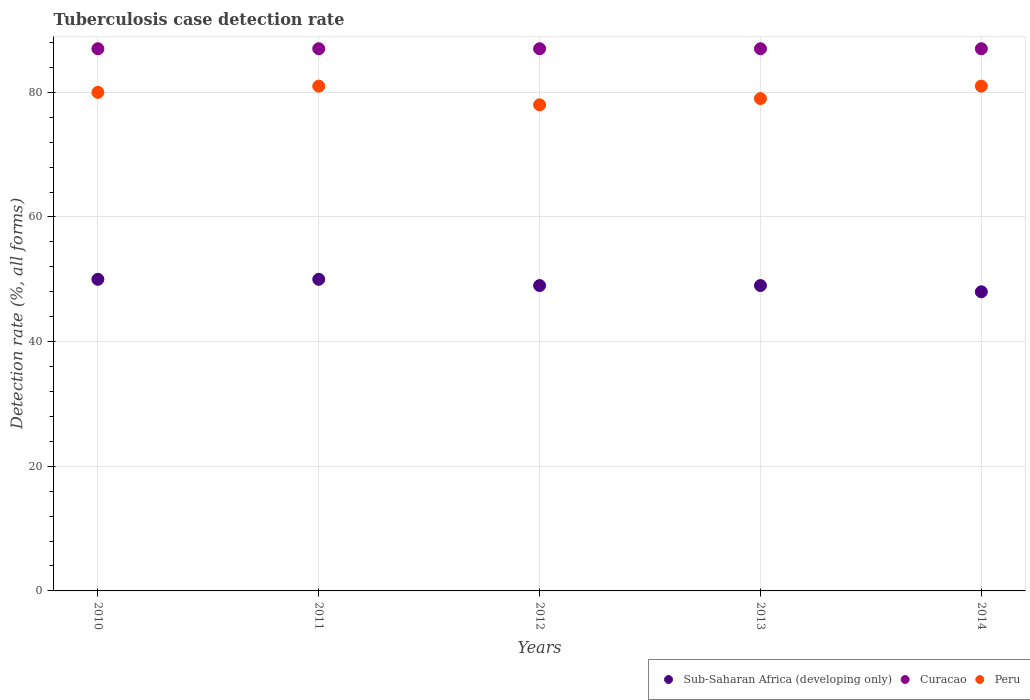How many different coloured dotlines are there?
Your answer should be very brief. 3. What is the tuberculosis case detection rate in in Sub-Saharan Africa (developing only) in 2011?
Provide a short and direct response. 50. Across all years, what is the maximum tuberculosis case detection rate in in Sub-Saharan Africa (developing only)?
Provide a succinct answer. 50. Across all years, what is the minimum tuberculosis case detection rate in in Curacao?
Keep it short and to the point. 87. In which year was the tuberculosis case detection rate in in Peru maximum?
Offer a terse response. 2011. In which year was the tuberculosis case detection rate in in Curacao minimum?
Ensure brevity in your answer.  2010. What is the total tuberculosis case detection rate in in Sub-Saharan Africa (developing only) in the graph?
Give a very brief answer. 246. What is the difference between the tuberculosis case detection rate in in Peru in 2011 and that in 2012?
Your answer should be very brief. 3. What is the difference between the tuberculosis case detection rate in in Peru in 2010 and the tuberculosis case detection rate in in Sub-Saharan Africa (developing only) in 2012?
Keep it short and to the point. 31. What is the average tuberculosis case detection rate in in Sub-Saharan Africa (developing only) per year?
Ensure brevity in your answer.  49.2. In the year 2013, what is the difference between the tuberculosis case detection rate in in Sub-Saharan Africa (developing only) and tuberculosis case detection rate in in Peru?
Give a very brief answer. -30. In how many years, is the tuberculosis case detection rate in in Sub-Saharan Africa (developing only) greater than 52 %?
Provide a succinct answer. 0. What is the ratio of the tuberculosis case detection rate in in Sub-Saharan Africa (developing only) in 2010 to that in 2012?
Provide a short and direct response. 1.02. What is the difference between the highest and the second highest tuberculosis case detection rate in in Sub-Saharan Africa (developing only)?
Offer a very short reply. 0. What is the difference between the highest and the lowest tuberculosis case detection rate in in Curacao?
Make the answer very short. 0. Is it the case that in every year, the sum of the tuberculosis case detection rate in in Sub-Saharan Africa (developing only) and tuberculosis case detection rate in in Curacao  is greater than the tuberculosis case detection rate in in Peru?
Offer a terse response. Yes. Is the tuberculosis case detection rate in in Peru strictly greater than the tuberculosis case detection rate in in Sub-Saharan Africa (developing only) over the years?
Make the answer very short. Yes. How many years are there in the graph?
Your answer should be very brief. 5. Are the values on the major ticks of Y-axis written in scientific E-notation?
Your answer should be compact. No. Does the graph contain any zero values?
Provide a succinct answer. No. Does the graph contain grids?
Your response must be concise. Yes. How are the legend labels stacked?
Keep it short and to the point. Horizontal. What is the title of the graph?
Give a very brief answer. Tuberculosis case detection rate. What is the label or title of the Y-axis?
Provide a short and direct response. Detection rate (%, all forms). What is the Detection rate (%, all forms) of Peru in 2010?
Provide a succinct answer. 80. What is the Detection rate (%, all forms) in Sub-Saharan Africa (developing only) in 2011?
Provide a succinct answer. 50. What is the Detection rate (%, all forms) in Curacao in 2011?
Keep it short and to the point. 87. What is the Detection rate (%, all forms) in Peru in 2012?
Make the answer very short. 78. What is the Detection rate (%, all forms) in Peru in 2013?
Ensure brevity in your answer.  79. What is the Detection rate (%, all forms) in Sub-Saharan Africa (developing only) in 2014?
Provide a short and direct response. 48. Across all years, what is the minimum Detection rate (%, all forms) in Curacao?
Your answer should be very brief. 87. What is the total Detection rate (%, all forms) of Sub-Saharan Africa (developing only) in the graph?
Your answer should be very brief. 246. What is the total Detection rate (%, all forms) of Curacao in the graph?
Offer a terse response. 435. What is the total Detection rate (%, all forms) in Peru in the graph?
Provide a short and direct response. 399. What is the difference between the Detection rate (%, all forms) in Sub-Saharan Africa (developing only) in 2010 and that in 2011?
Your answer should be very brief. 0. What is the difference between the Detection rate (%, all forms) in Peru in 2010 and that in 2011?
Give a very brief answer. -1. What is the difference between the Detection rate (%, all forms) in Peru in 2010 and that in 2014?
Provide a short and direct response. -1. What is the difference between the Detection rate (%, all forms) of Curacao in 2011 and that in 2012?
Keep it short and to the point. 0. What is the difference between the Detection rate (%, all forms) of Peru in 2011 and that in 2012?
Make the answer very short. 3. What is the difference between the Detection rate (%, all forms) in Sub-Saharan Africa (developing only) in 2011 and that in 2014?
Ensure brevity in your answer.  2. What is the difference between the Detection rate (%, all forms) in Peru in 2011 and that in 2014?
Provide a short and direct response. 0. What is the difference between the Detection rate (%, all forms) in Curacao in 2012 and that in 2013?
Offer a terse response. 0. What is the difference between the Detection rate (%, all forms) of Peru in 2012 and that in 2014?
Provide a short and direct response. -3. What is the difference between the Detection rate (%, all forms) of Curacao in 2013 and that in 2014?
Provide a short and direct response. 0. What is the difference between the Detection rate (%, all forms) of Sub-Saharan Africa (developing only) in 2010 and the Detection rate (%, all forms) of Curacao in 2011?
Offer a very short reply. -37. What is the difference between the Detection rate (%, all forms) in Sub-Saharan Africa (developing only) in 2010 and the Detection rate (%, all forms) in Peru in 2011?
Keep it short and to the point. -31. What is the difference between the Detection rate (%, all forms) of Curacao in 2010 and the Detection rate (%, all forms) of Peru in 2011?
Offer a terse response. 6. What is the difference between the Detection rate (%, all forms) of Sub-Saharan Africa (developing only) in 2010 and the Detection rate (%, all forms) of Curacao in 2012?
Keep it short and to the point. -37. What is the difference between the Detection rate (%, all forms) in Sub-Saharan Africa (developing only) in 2010 and the Detection rate (%, all forms) in Curacao in 2013?
Your answer should be very brief. -37. What is the difference between the Detection rate (%, all forms) in Sub-Saharan Africa (developing only) in 2010 and the Detection rate (%, all forms) in Peru in 2013?
Make the answer very short. -29. What is the difference between the Detection rate (%, all forms) of Curacao in 2010 and the Detection rate (%, all forms) of Peru in 2013?
Your answer should be very brief. 8. What is the difference between the Detection rate (%, all forms) of Sub-Saharan Africa (developing only) in 2010 and the Detection rate (%, all forms) of Curacao in 2014?
Your response must be concise. -37. What is the difference between the Detection rate (%, all forms) in Sub-Saharan Africa (developing only) in 2010 and the Detection rate (%, all forms) in Peru in 2014?
Offer a terse response. -31. What is the difference between the Detection rate (%, all forms) of Sub-Saharan Africa (developing only) in 2011 and the Detection rate (%, all forms) of Curacao in 2012?
Your response must be concise. -37. What is the difference between the Detection rate (%, all forms) of Sub-Saharan Africa (developing only) in 2011 and the Detection rate (%, all forms) of Peru in 2012?
Provide a succinct answer. -28. What is the difference between the Detection rate (%, all forms) in Sub-Saharan Africa (developing only) in 2011 and the Detection rate (%, all forms) in Curacao in 2013?
Ensure brevity in your answer.  -37. What is the difference between the Detection rate (%, all forms) of Sub-Saharan Africa (developing only) in 2011 and the Detection rate (%, all forms) of Peru in 2013?
Provide a short and direct response. -29. What is the difference between the Detection rate (%, all forms) in Sub-Saharan Africa (developing only) in 2011 and the Detection rate (%, all forms) in Curacao in 2014?
Give a very brief answer. -37. What is the difference between the Detection rate (%, all forms) in Sub-Saharan Africa (developing only) in 2011 and the Detection rate (%, all forms) in Peru in 2014?
Provide a succinct answer. -31. What is the difference between the Detection rate (%, all forms) of Sub-Saharan Africa (developing only) in 2012 and the Detection rate (%, all forms) of Curacao in 2013?
Make the answer very short. -38. What is the difference between the Detection rate (%, all forms) in Curacao in 2012 and the Detection rate (%, all forms) in Peru in 2013?
Keep it short and to the point. 8. What is the difference between the Detection rate (%, all forms) in Sub-Saharan Africa (developing only) in 2012 and the Detection rate (%, all forms) in Curacao in 2014?
Offer a terse response. -38. What is the difference between the Detection rate (%, all forms) in Sub-Saharan Africa (developing only) in 2012 and the Detection rate (%, all forms) in Peru in 2014?
Make the answer very short. -32. What is the difference between the Detection rate (%, all forms) in Curacao in 2012 and the Detection rate (%, all forms) in Peru in 2014?
Your response must be concise. 6. What is the difference between the Detection rate (%, all forms) in Sub-Saharan Africa (developing only) in 2013 and the Detection rate (%, all forms) in Curacao in 2014?
Your answer should be compact. -38. What is the difference between the Detection rate (%, all forms) in Sub-Saharan Africa (developing only) in 2013 and the Detection rate (%, all forms) in Peru in 2014?
Ensure brevity in your answer.  -32. What is the average Detection rate (%, all forms) of Sub-Saharan Africa (developing only) per year?
Give a very brief answer. 49.2. What is the average Detection rate (%, all forms) in Peru per year?
Give a very brief answer. 79.8. In the year 2010, what is the difference between the Detection rate (%, all forms) in Sub-Saharan Africa (developing only) and Detection rate (%, all forms) in Curacao?
Ensure brevity in your answer.  -37. In the year 2010, what is the difference between the Detection rate (%, all forms) in Sub-Saharan Africa (developing only) and Detection rate (%, all forms) in Peru?
Your answer should be very brief. -30. In the year 2010, what is the difference between the Detection rate (%, all forms) of Curacao and Detection rate (%, all forms) of Peru?
Make the answer very short. 7. In the year 2011, what is the difference between the Detection rate (%, all forms) of Sub-Saharan Africa (developing only) and Detection rate (%, all forms) of Curacao?
Offer a very short reply. -37. In the year 2011, what is the difference between the Detection rate (%, all forms) in Sub-Saharan Africa (developing only) and Detection rate (%, all forms) in Peru?
Your answer should be very brief. -31. In the year 2011, what is the difference between the Detection rate (%, all forms) of Curacao and Detection rate (%, all forms) of Peru?
Your answer should be compact. 6. In the year 2012, what is the difference between the Detection rate (%, all forms) of Sub-Saharan Africa (developing only) and Detection rate (%, all forms) of Curacao?
Keep it short and to the point. -38. In the year 2012, what is the difference between the Detection rate (%, all forms) of Sub-Saharan Africa (developing only) and Detection rate (%, all forms) of Peru?
Your response must be concise. -29. In the year 2012, what is the difference between the Detection rate (%, all forms) in Curacao and Detection rate (%, all forms) in Peru?
Your response must be concise. 9. In the year 2013, what is the difference between the Detection rate (%, all forms) of Sub-Saharan Africa (developing only) and Detection rate (%, all forms) of Curacao?
Your response must be concise. -38. In the year 2013, what is the difference between the Detection rate (%, all forms) in Sub-Saharan Africa (developing only) and Detection rate (%, all forms) in Peru?
Your response must be concise. -30. In the year 2013, what is the difference between the Detection rate (%, all forms) in Curacao and Detection rate (%, all forms) in Peru?
Offer a terse response. 8. In the year 2014, what is the difference between the Detection rate (%, all forms) of Sub-Saharan Africa (developing only) and Detection rate (%, all forms) of Curacao?
Your answer should be compact. -39. In the year 2014, what is the difference between the Detection rate (%, all forms) in Sub-Saharan Africa (developing only) and Detection rate (%, all forms) in Peru?
Provide a short and direct response. -33. What is the ratio of the Detection rate (%, all forms) of Sub-Saharan Africa (developing only) in 2010 to that in 2012?
Offer a terse response. 1.02. What is the ratio of the Detection rate (%, all forms) in Curacao in 2010 to that in 2012?
Give a very brief answer. 1. What is the ratio of the Detection rate (%, all forms) of Peru in 2010 to that in 2012?
Give a very brief answer. 1.03. What is the ratio of the Detection rate (%, all forms) of Sub-Saharan Africa (developing only) in 2010 to that in 2013?
Offer a very short reply. 1.02. What is the ratio of the Detection rate (%, all forms) in Curacao in 2010 to that in 2013?
Ensure brevity in your answer.  1. What is the ratio of the Detection rate (%, all forms) in Peru in 2010 to that in 2013?
Your response must be concise. 1.01. What is the ratio of the Detection rate (%, all forms) in Sub-Saharan Africa (developing only) in 2010 to that in 2014?
Your answer should be compact. 1.04. What is the ratio of the Detection rate (%, all forms) in Peru in 2010 to that in 2014?
Give a very brief answer. 0.99. What is the ratio of the Detection rate (%, all forms) in Sub-Saharan Africa (developing only) in 2011 to that in 2012?
Offer a very short reply. 1.02. What is the ratio of the Detection rate (%, all forms) in Curacao in 2011 to that in 2012?
Your answer should be compact. 1. What is the ratio of the Detection rate (%, all forms) of Peru in 2011 to that in 2012?
Keep it short and to the point. 1.04. What is the ratio of the Detection rate (%, all forms) in Sub-Saharan Africa (developing only) in 2011 to that in 2013?
Offer a terse response. 1.02. What is the ratio of the Detection rate (%, all forms) in Peru in 2011 to that in 2013?
Provide a succinct answer. 1.03. What is the ratio of the Detection rate (%, all forms) in Sub-Saharan Africa (developing only) in 2011 to that in 2014?
Ensure brevity in your answer.  1.04. What is the ratio of the Detection rate (%, all forms) in Peru in 2011 to that in 2014?
Offer a very short reply. 1. What is the ratio of the Detection rate (%, all forms) of Curacao in 2012 to that in 2013?
Your answer should be compact. 1. What is the ratio of the Detection rate (%, all forms) in Peru in 2012 to that in 2013?
Your response must be concise. 0.99. What is the ratio of the Detection rate (%, all forms) in Sub-Saharan Africa (developing only) in 2012 to that in 2014?
Make the answer very short. 1.02. What is the ratio of the Detection rate (%, all forms) in Sub-Saharan Africa (developing only) in 2013 to that in 2014?
Offer a terse response. 1.02. What is the ratio of the Detection rate (%, all forms) of Peru in 2013 to that in 2014?
Provide a succinct answer. 0.98. What is the difference between the highest and the second highest Detection rate (%, all forms) of Sub-Saharan Africa (developing only)?
Keep it short and to the point. 0. What is the difference between the highest and the second highest Detection rate (%, all forms) in Curacao?
Provide a succinct answer. 0. What is the difference between the highest and the lowest Detection rate (%, all forms) of Curacao?
Your response must be concise. 0. What is the difference between the highest and the lowest Detection rate (%, all forms) in Peru?
Your answer should be very brief. 3. 